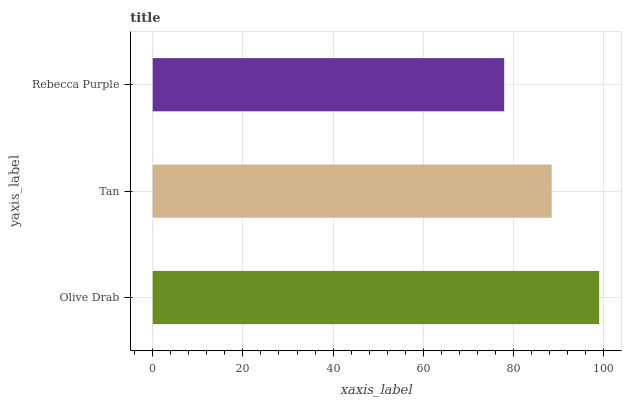Is Rebecca Purple the minimum?
Answer yes or no. Yes. Is Olive Drab the maximum?
Answer yes or no. Yes. Is Tan the minimum?
Answer yes or no. No. Is Tan the maximum?
Answer yes or no. No. Is Olive Drab greater than Tan?
Answer yes or no. Yes. Is Tan less than Olive Drab?
Answer yes or no. Yes. Is Tan greater than Olive Drab?
Answer yes or no. No. Is Olive Drab less than Tan?
Answer yes or no. No. Is Tan the high median?
Answer yes or no. Yes. Is Tan the low median?
Answer yes or no. Yes. Is Rebecca Purple the high median?
Answer yes or no. No. Is Rebecca Purple the low median?
Answer yes or no. No. 